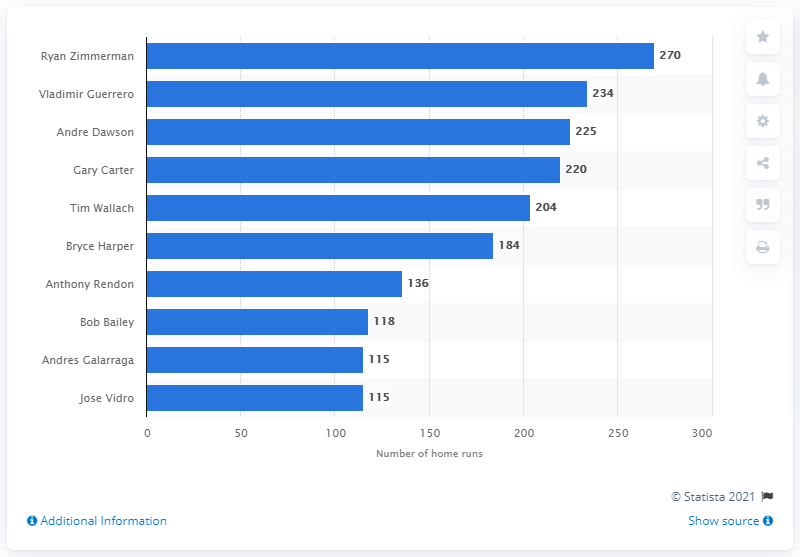Identify some key points in this picture. Ryan Zimmerman has hit 270 home runs. Ryan Zimmerman is the Washington Nationals franchise player who has hit the most home runs in the team's history. 